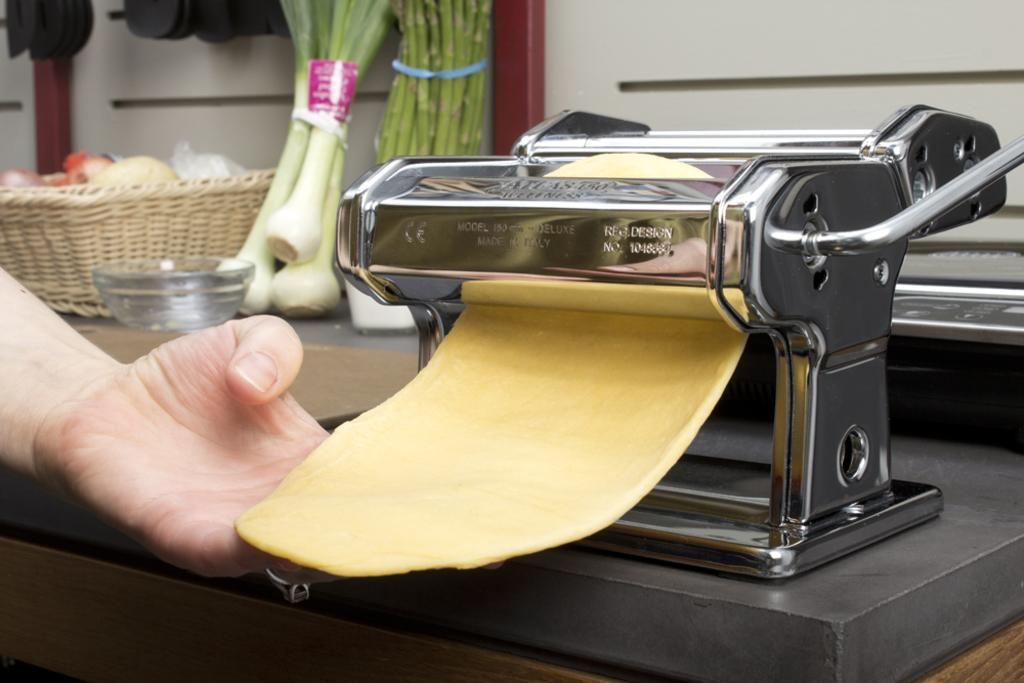<image>
Write a terse but informative summary of the picture. A person flattens a type of dough through a machine with RFG. Design written on it. 